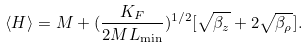Convert formula to latex. <formula><loc_0><loc_0><loc_500><loc_500>\langle H \rangle = M + ( \frac { K _ { F } } { 2 M L _ { \min } } ) ^ { 1 / 2 } [ \sqrt { \beta _ { z } } + 2 \sqrt { \beta _ { \rho } } ] .</formula> 